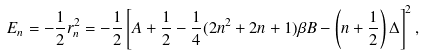Convert formula to latex. <formula><loc_0><loc_0><loc_500><loc_500>E _ { n } = - \frac { 1 } { 2 } r _ { n } ^ { 2 } = - \frac { 1 } { 2 } \left [ A + \frac { 1 } { 2 } - \frac { 1 } { 4 } ( 2 n ^ { 2 } + 2 n + 1 ) \beta B - \left ( n + \frac { 1 } { 2 } \right ) \Delta \right ] ^ { 2 } ,</formula> 